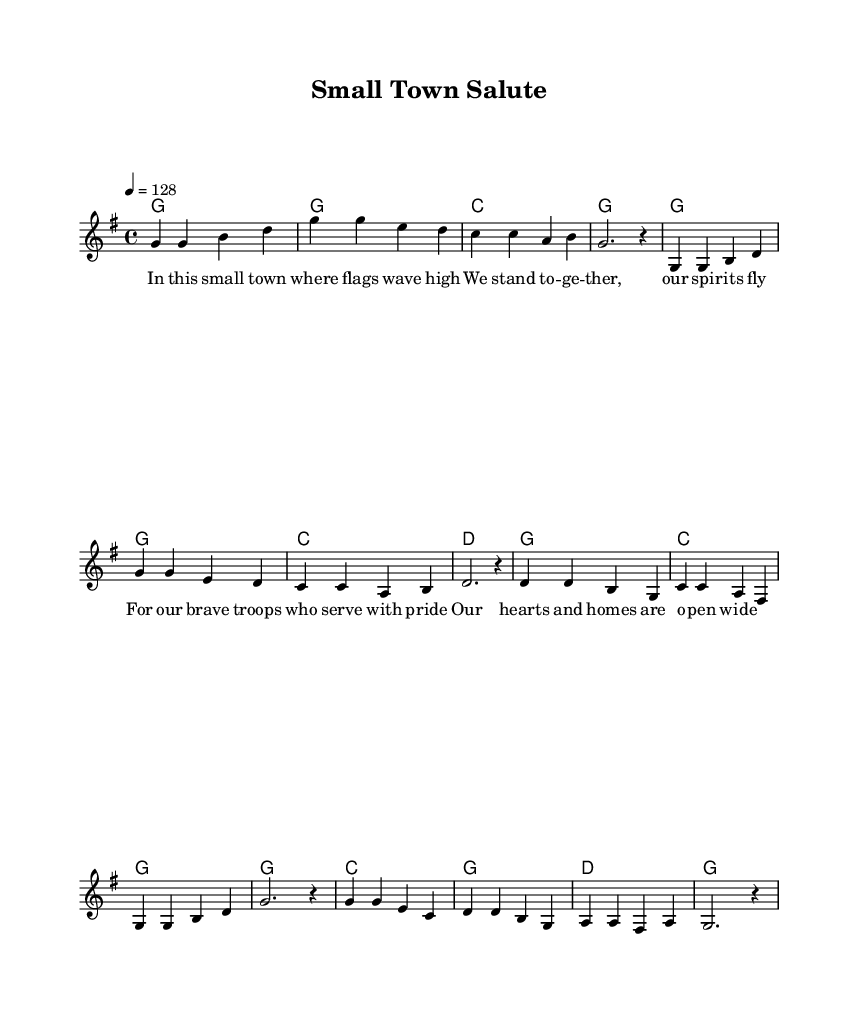What is the key signature of this music? The key signature is G major, indicated by one sharp (F#), which is shown at the beginning of the score.
Answer: G major What is the time signature of this music? The time signature appears at the start and is indicated as 4/4, meaning there are four beats per measure.
Answer: 4/4 What is the tempo marking for this piece? The tempo marking specifies the speed as 4 equals 128, indicating a lively pace of 128 beats per minute.
Answer: 128 What is the title of this piece? The title "Small Town Salute" is prominently displayed in the header section of the sheet music.
Answer: Small Town Salute How many measures are in the melody? By counting the individual measures shown in the melody, there are a total of 8 measures provided in the notation.
Answer: 8 Which chord appears most frequently in the harmonies? By analyzing the chord progression, the G chord appears most commonly throughout the score, present in multiple measures.
Answer: G What is the primary theme of the lyrics? The lyrics convey a theme of community support for troops and pride in small-town values, as reflected in the text.
Answer: Community support 